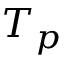<formula> <loc_0><loc_0><loc_500><loc_500>T _ { p }</formula> 